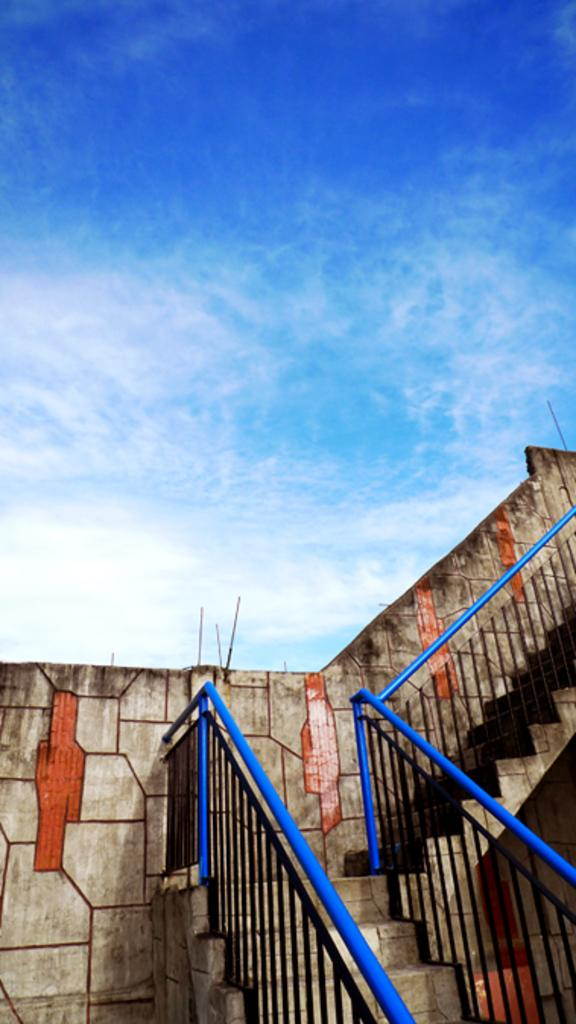What can be seen in the foreground of the image? In the foreground of the image, there are stairs, a railing, and a wall. What is the purpose of the railing in the image? The railing is likely there for safety, to prevent people from falling while using the stairs. What is visible at the top of the image? The sky is visible at the top of the image. What can be observed in the sky? There are clouds in the sky. What type of substance is being transported in the letter in the image? There is no letter or substance being transported in the image; it features stairs, a railing, and a wall in the foreground, with clouds in the sky. 